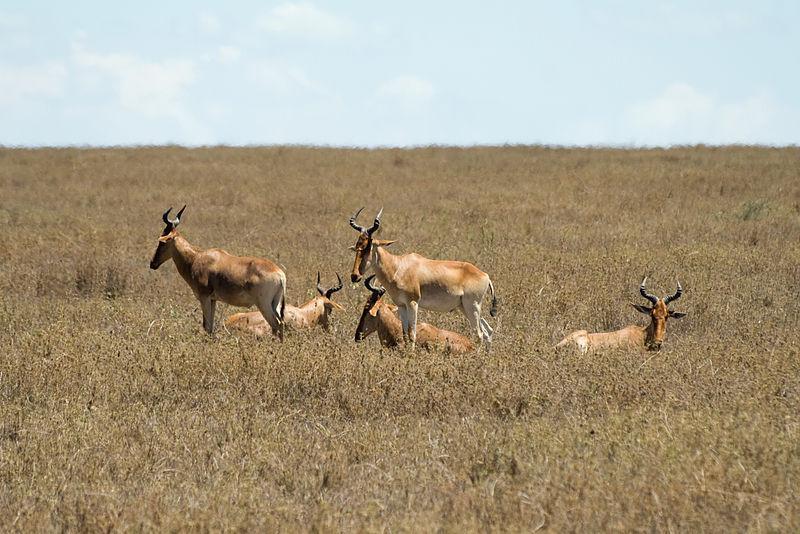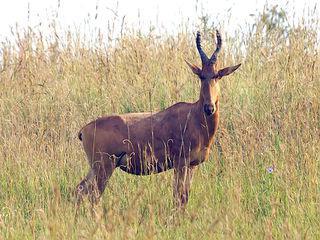The first image is the image on the left, the second image is the image on the right. Examine the images to the left and right. Is the description "An image shows exactly five hooved animals with horns." accurate? Answer yes or no. Yes. The first image is the image on the left, the second image is the image on the right. Considering the images on both sides, is "there is exactly one animal in the image on the left" valid? Answer yes or no. No. 